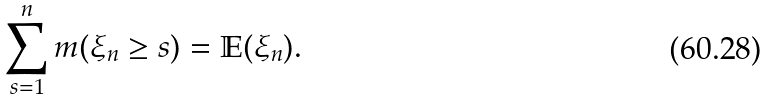Convert formula to latex. <formula><loc_0><loc_0><loc_500><loc_500>\sum _ { s = 1 } ^ { n } m ( \xi _ { n } \geq s ) = \mathbb { E } ( \xi _ { n } ) .</formula> 